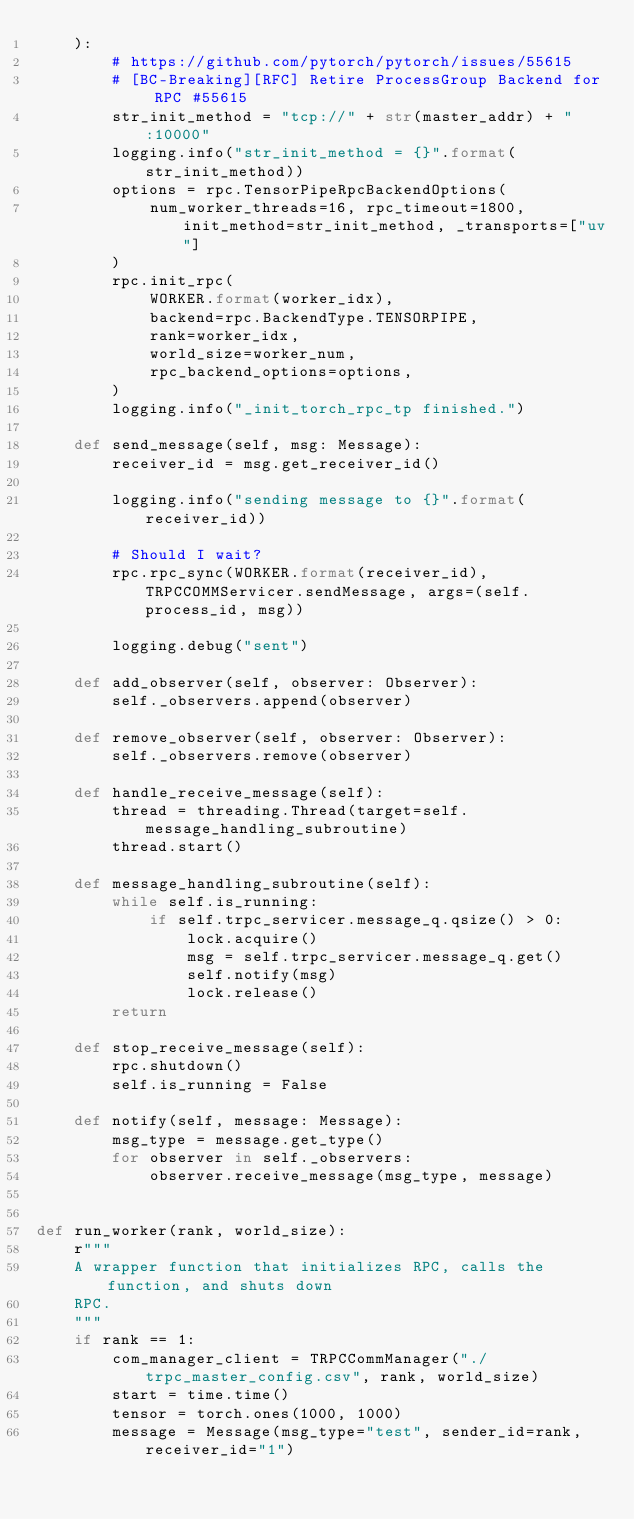<code> <loc_0><loc_0><loc_500><loc_500><_Python_>    ):
        # https://github.com/pytorch/pytorch/issues/55615
        # [BC-Breaking][RFC] Retire ProcessGroup Backend for RPC #55615
        str_init_method = "tcp://" + str(master_addr) + ":10000"
        logging.info("str_init_method = {}".format(str_init_method))
        options = rpc.TensorPipeRpcBackendOptions(
            num_worker_threads=16, rpc_timeout=1800, init_method=str_init_method, _transports=["uv"]
        )
        rpc.init_rpc(
            WORKER.format(worker_idx),
            backend=rpc.BackendType.TENSORPIPE,
            rank=worker_idx,
            world_size=worker_num,
            rpc_backend_options=options,
        )
        logging.info("_init_torch_rpc_tp finished.")

    def send_message(self, msg: Message):
        receiver_id = msg.get_receiver_id()

        logging.info("sending message to {}".format(receiver_id))

        # Should I wait?
        rpc.rpc_sync(WORKER.format(receiver_id), TRPCCOMMServicer.sendMessage, args=(self.process_id, msg))

        logging.debug("sent")

    def add_observer(self, observer: Observer):
        self._observers.append(observer)

    def remove_observer(self, observer: Observer):
        self._observers.remove(observer)

    def handle_receive_message(self):
        thread = threading.Thread(target=self.message_handling_subroutine)
        thread.start()

    def message_handling_subroutine(self):
        while self.is_running:
            if self.trpc_servicer.message_q.qsize() > 0:
                lock.acquire()
                msg = self.trpc_servicer.message_q.get()
                self.notify(msg)
                lock.release()
        return

    def stop_receive_message(self):
        rpc.shutdown()
        self.is_running = False

    def notify(self, message: Message):
        msg_type = message.get_type()
        for observer in self._observers:
            observer.receive_message(msg_type, message)


def run_worker(rank, world_size):
    r"""
    A wrapper function that initializes RPC, calls the function, and shuts down
    RPC.
    """
    if rank == 1:
        com_manager_client = TRPCCommManager("./trpc_master_config.csv", rank, world_size)
        start = time.time()
        tensor = torch.ones(1000, 1000)
        message = Message(msg_type="test", sender_id=rank, receiver_id="1")</code> 